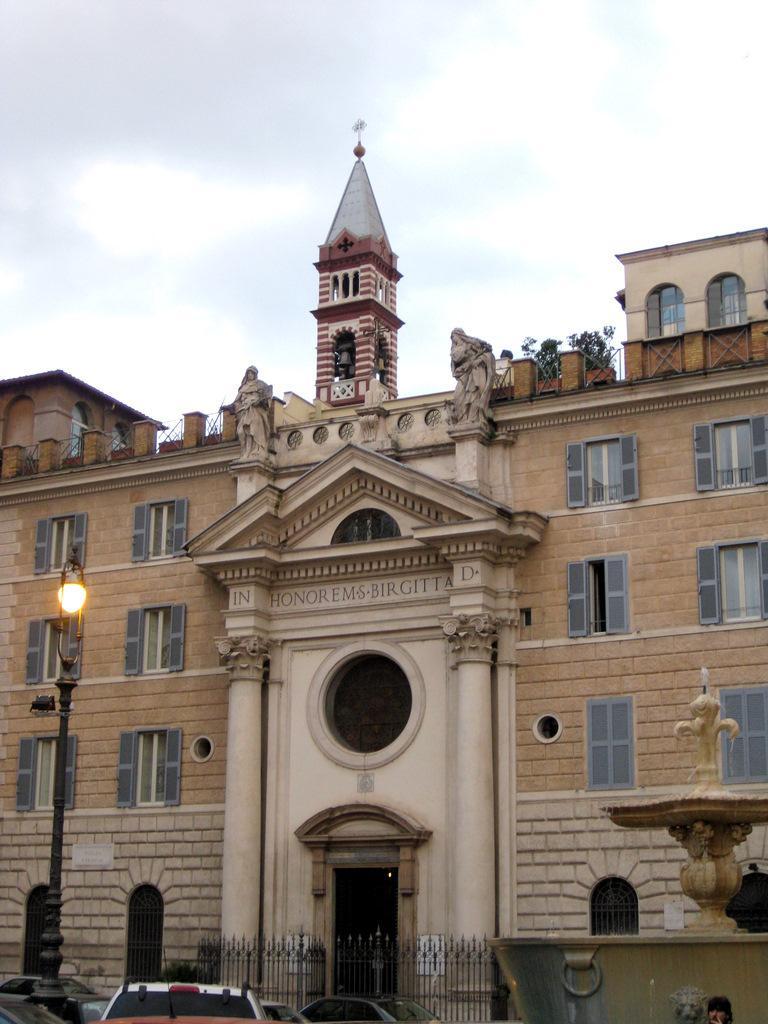Please provide a concise description of this image. This picture is clicked outside. In the foreground we can see the group of vehicles, light attached to the pole and we can see the metal fence and some other objects. In the center there is a building and we can sculptures and the windows and the wall of the building. In the background there is a sky. 